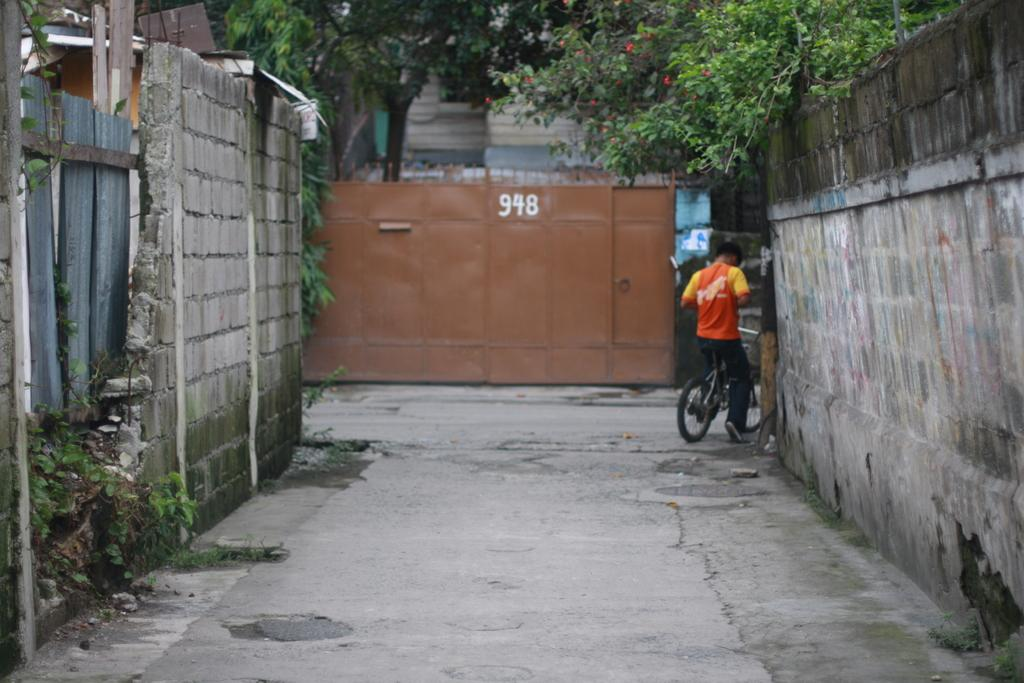<image>
Share a concise interpretation of the image provided. An alleyway with a brown metal bin at the end that says 948. 